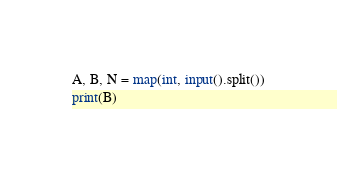<code> <loc_0><loc_0><loc_500><loc_500><_Python_>A, B, N = map(int, input().split())
print(B)</code> 